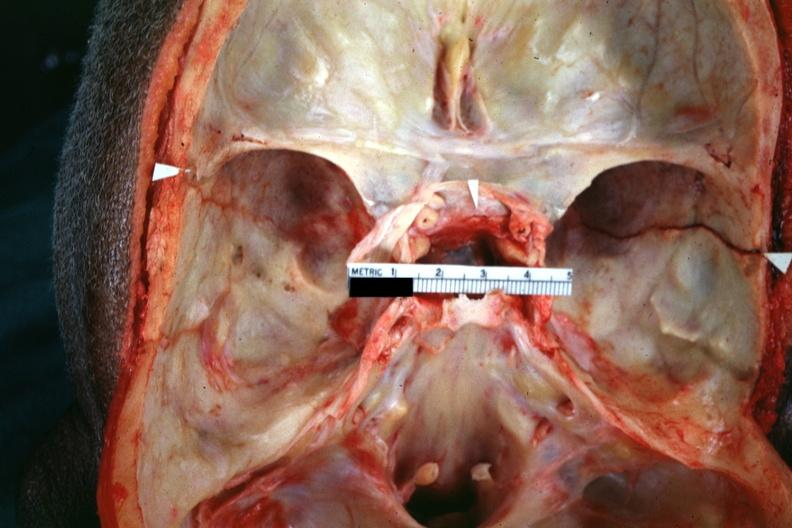how is close-up view shown line?
Answer the question using a single word or phrase. Fracture 